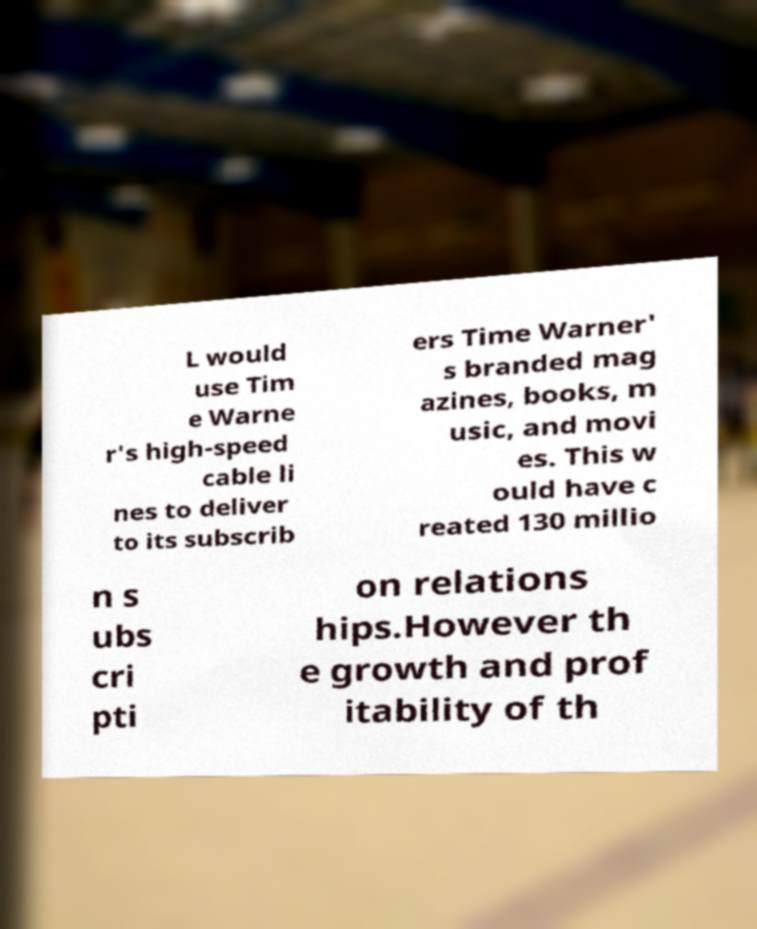For documentation purposes, I need the text within this image transcribed. Could you provide that? L would use Tim e Warne r's high-speed cable li nes to deliver to its subscrib ers Time Warner' s branded mag azines, books, m usic, and movi es. This w ould have c reated 130 millio n s ubs cri pti on relations hips.However th e growth and prof itability of th 